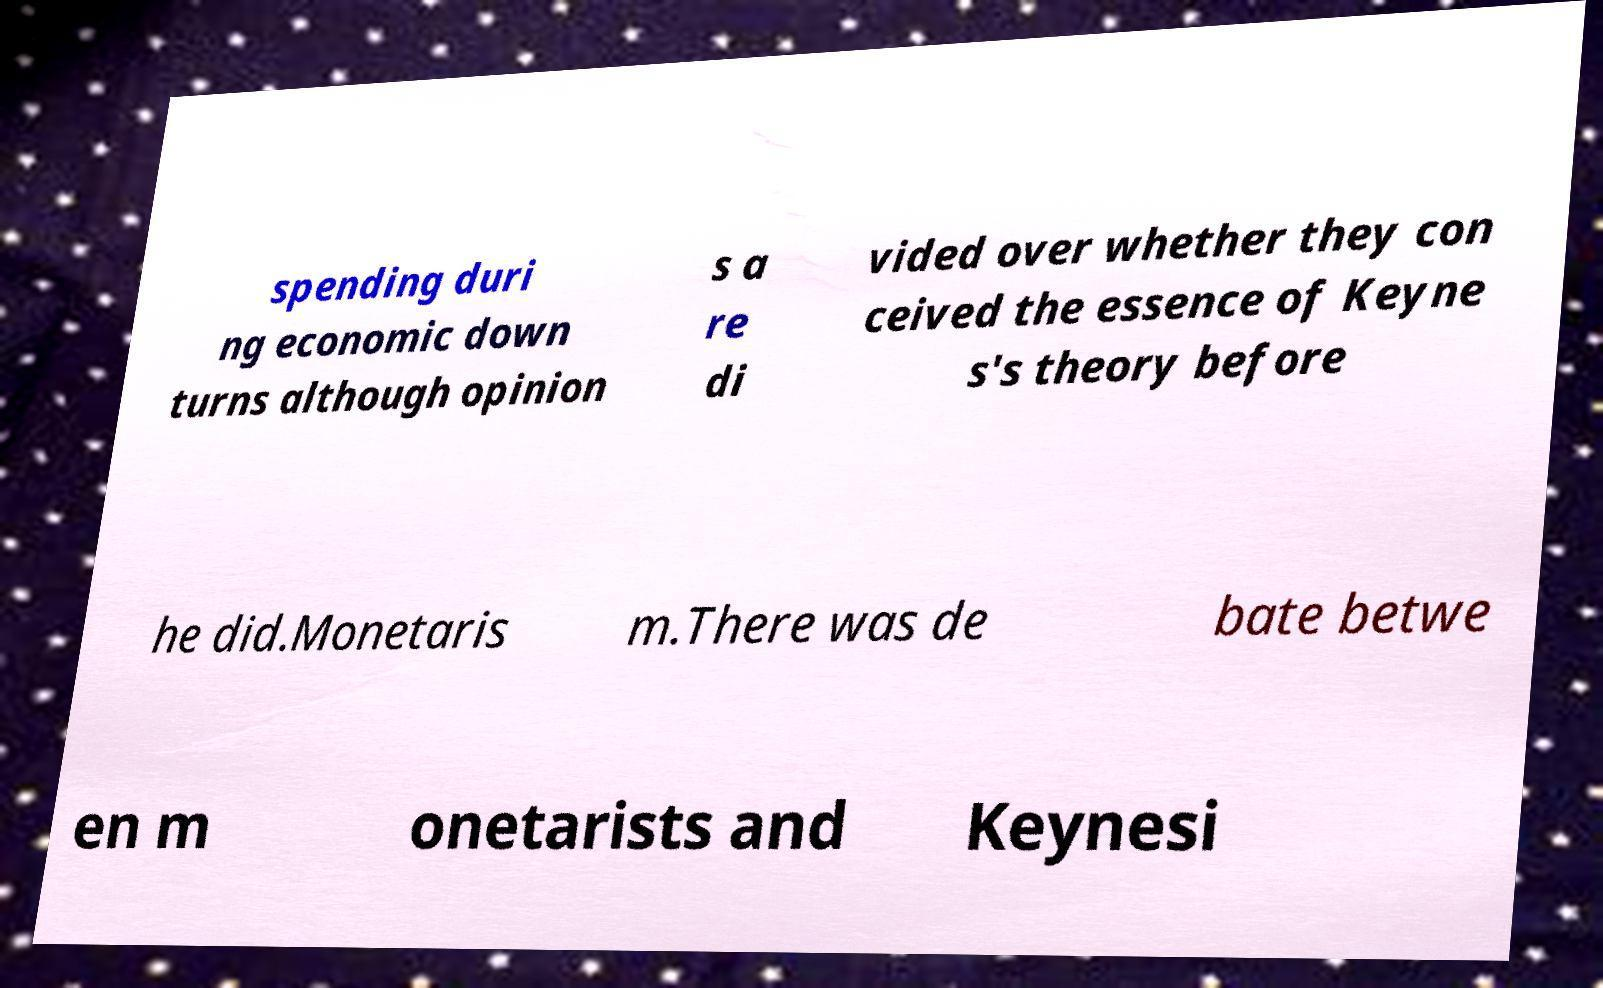Can you read and provide the text displayed in the image?This photo seems to have some interesting text. Can you extract and type it out for me? spending duri ng economic down turns although opinion s a re di vided over whether they con ceived the essence of Keyne s's theory before he did.Monetaris m.There was de bate betwe en m onetarists and Keynesi 